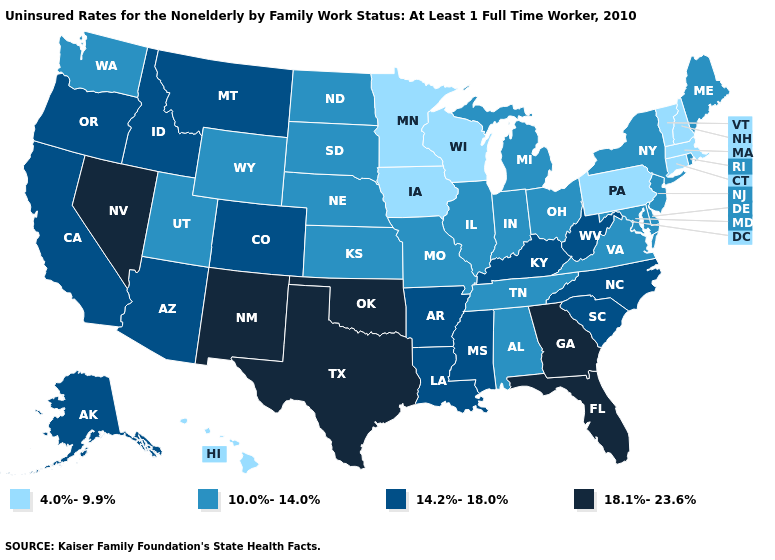What is the value of Kansas?
Keep it brief. 10.0%-14.0%. What is the highest value in the USA?
Short answer required. 18.1%-23.6%. What is the highest value in states that border Vermont?
Answer briefly. 10.0%-14.0%. What is the value of Arkansas?
Concise answer only. 14.2%-18.0%. Does Iowa have a lower value than Oklahoma?
Short answer required. Yes. Name the states that have a value in the range 10.0%-14.0%?
Keep it brief. Alabama, Delaware, Illinois, Indiana, Kansas, Maine, Maryland, Michigan, Missouri, Nebraska, New Jersey, New York, North Dakota, Ohio, Rhode Island, South Dakota, Tennessee, Utah, Virginia, Washington, Wyoming. Which states have the lowest value in the Northeast?
Be succinct. Connecticut, Massachusetts, New Hampshire, Pennsylvania, Vermont. What is the lowest value in the MidWest?
Keep it brief. 4.0%-9.9%. Name the states that have a value in the range 4.0%-9.9%?
Give a very brief answer. Connecticut, Hawaii, Iowa, Massachusetts, Minnesota, New Hampshire, Pennsylvania, Vermont, Wisconsin. Name the states that have a value in the range 18.1%-23.6%?
Quick response, please. Florida, Georgia, Nevada, New Mexico, Oklahoma, Texas. What is the value of Massachusetts?
Write a very short answer. 4.0%-9.9%. Which states have the lowest value in the South?
Give a very brief answer. Alabama, Delaware, Maryland, Tennessee, Virginia. What is the value of Maine?
Write a very short answer. 10.0%-14.0%. Which states have the lowest value in the West?
Keep it brief. Hawaii. 